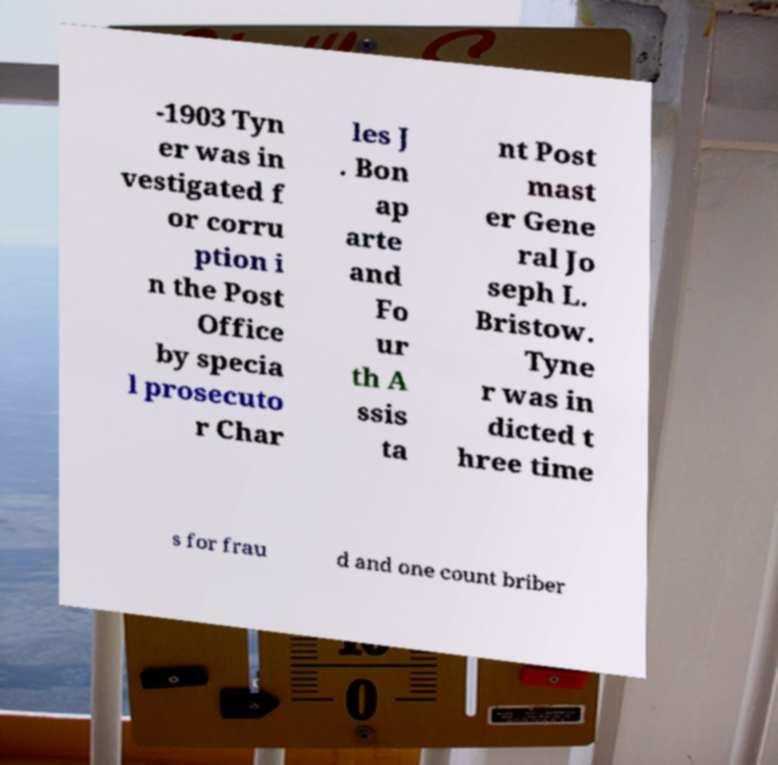Could you assist in decoding the text presented in this image and type it out clearly? -1903 Tyn er was in vestigated f or corru ption i n the Post Office by specia l prosecuto r Char les J . Bon ap arte and Fo ur th A ssis ta nt Post mast er Gene ral Jo seph L. Bristow. Tyne r was in dicted t hree time s for frau d and one count briber 